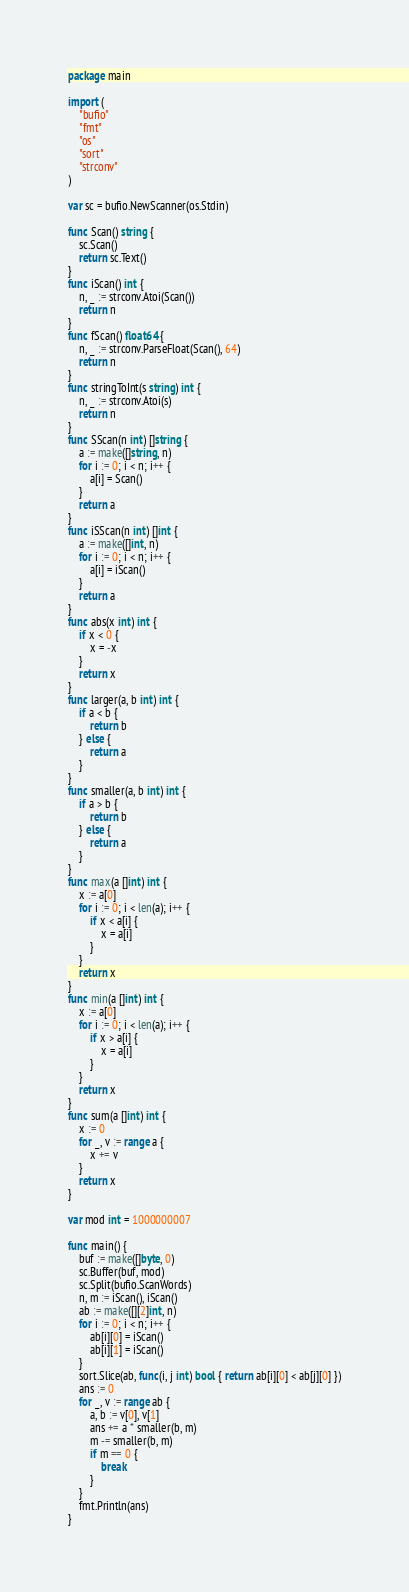<code> <loc_0><loc_0><loc_500><loc_500><_Go_>package main

import (
	"bufio"
	"fmt"
	"os"
	"sort"
	"strconv"
)

var sc = bufio.NewScanner(os.Stdin)

func Scan() string {
	sc.Scan()
	return sc.Text()
}
func iScan() int {
	n, _ := strconv.Atoi(Scan())
	return n
}
func fScan() float64 {
	n, _ := strconv.ParseFloat(Scan(), 64)
	return n
}
func stringToInt(s string) int {
	n, _ := strconv.Atoi(s)
	return n
}
func SScan(n int) []string {
	a := make([]string, n)
	for i := 0; i < n; i++ {
		a[i] = Scan()
	}
	return a
}
func iSScan(n int) []int {
	a := make([]int, n)
	for i := 0; i < n; i++ {
		a[i] = iScan()
	}
	return a
}
func abs(x int) int {
	if x < 0 {
		x = -x
	}
	return x
}
func larger(a, b int) int {
	if a < b {
		return b
	} else {
		return a
	}
}
func smaller(a, b int) int {
	if a > b {
		return b
	} else {
		return a
	}
}
func max(a []int) int {
	x := a[0]
	for i := 0; i < len(a); i++ {
		if x < a[i] {
			x = a[i]
		}
	}
	return x
}
func min(a []int) int {
	x := a[0]
	for i := 0; i < len(a); i++ {
		if x > a[i] {
			x = a[i]
		}
	}
	return x
}
func sum(a []int) int {
	x := 0
	for _, v := range a {
		x += v
	}
	return x
}

var mod int = 1000000007

func main() {
	buf := make([]byte, 0)
	sc.Buffer(buf, mod)
	sc.Split(bufio.ScanWords)
	n, m := iScan(), iScan()
	ab := make([][2]int, n)
	for i := 0; i < n; i++ {
		ab[i][0] = iScan()
		ab[i][1] = iScan()
	}
	sort.Slice(ab, func(i, j int) bool { return ab[i][0] < ab[j][0] })
	ans := 0
	for _, v := range ab {
		a, b := v[0], v[1]
		ans += a * smaller(b, m)
		m -= smaller(b, m)
		if m == 0 {
			break
		}
	}
	fmt.Println(ans)
}
</code> 